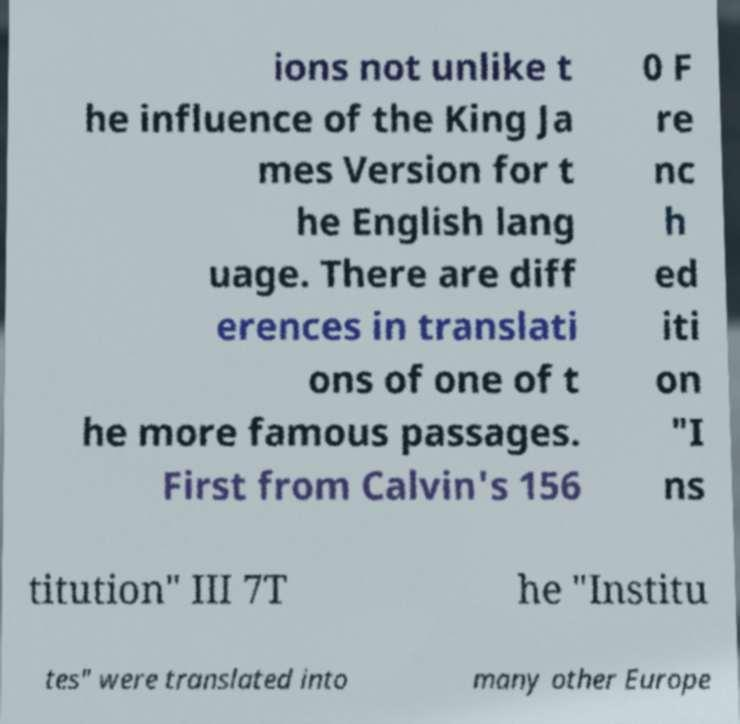Can you accurately transcribe the text from the provided image for me? ions not unlike t he influence of the King Ja mes Version for t he English lang uage. There are diff erences in translati ons of one of t he more famous passages. First from Calvin's 156 0 F re nc h ed iti on "I ns titution" III 7T he "Institu tes" were translated into many other Europe 